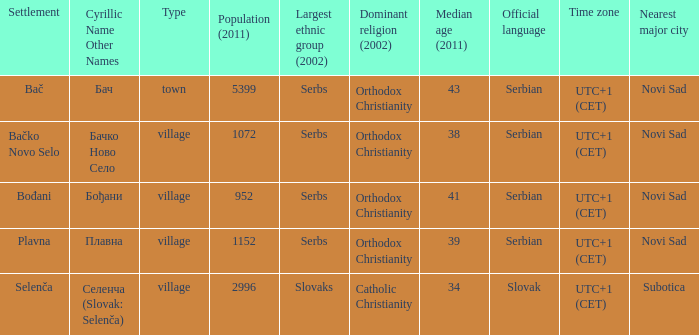What is the smallest population listed? 952.0. 